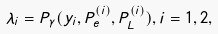Convert formula to latex. <formula><loc_0><loc_0><loc_500><loc_500>\lambda _ { i } = P _ { \gamma } ( y _ { i } , P _ { e } ^ { ( i ) } , P _ { L } ^ { ( i ) } ) , i = 1 , 2 ,</formula> 